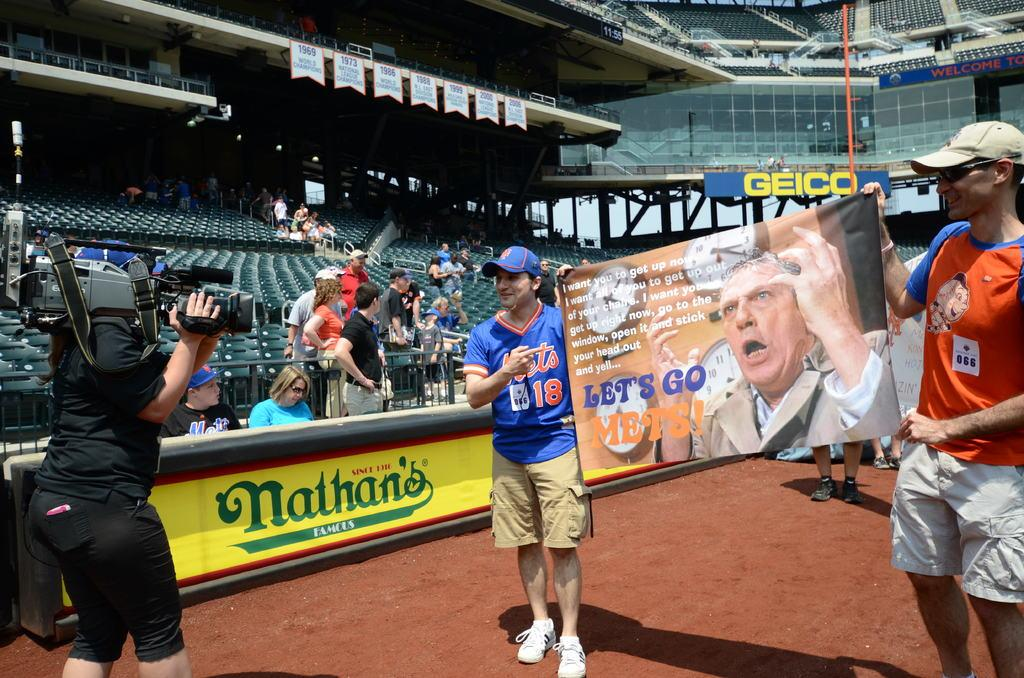<image>
Describe the image concisely. Nathan's Famous Hot Dogs is a sponsor of this baseball stadium. 